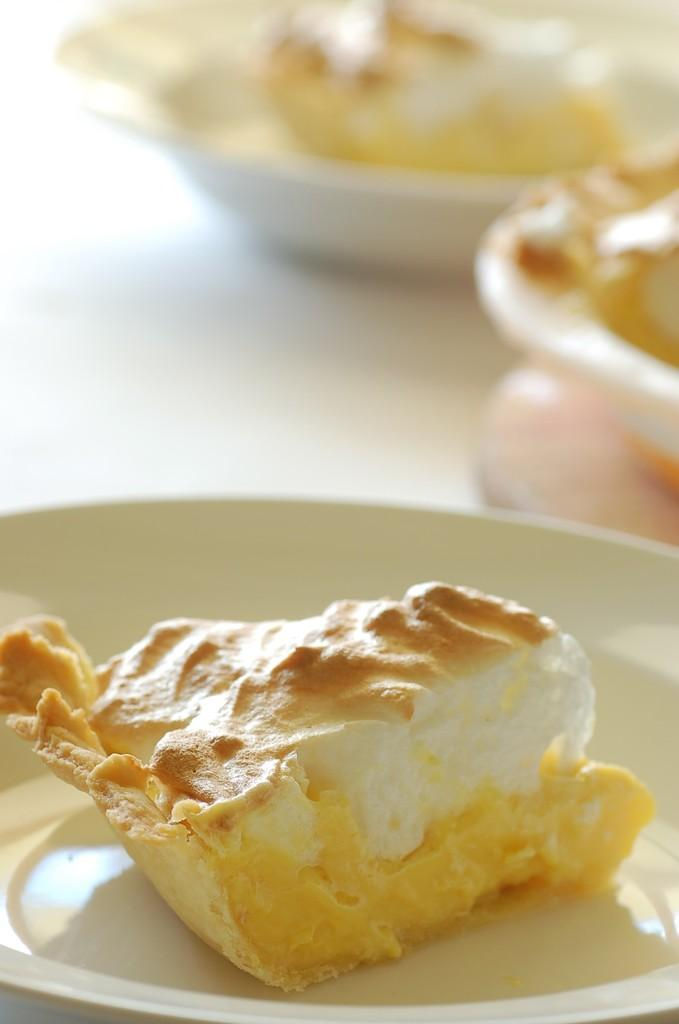What is present in the image related to eating? There is food in the image. How are the food items arranged in the image? The food is in plates. Where are the plates with food located? The plates with food are placed on a table. What type of pets can be seen playing with a fan in the image? There are no pets or fans present in the image; it only features food in plates on a table. 